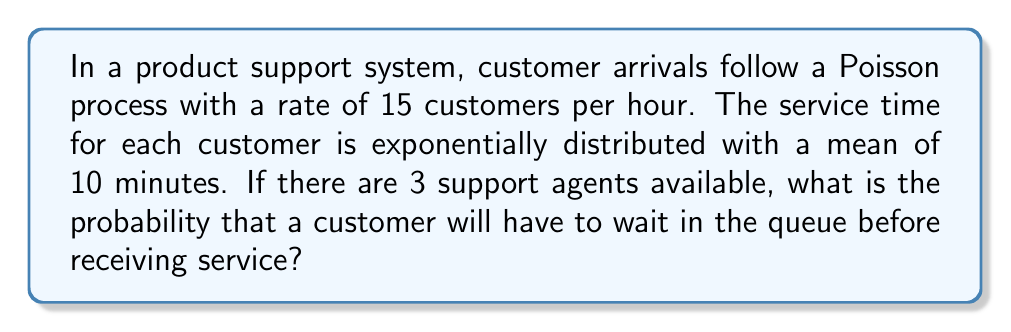What is the answer to this math problem? To solve this problem, we'll use the M/M/c queuing model, where M/M indicates Markovian arrival and service processes, and c is the number of servers (support agents in this case).

Step 1: Calculate the arrival rate (λ) and service rate (μ)
λ = 15 customers/hour
μ = 1 / (10/60) = 6 customers/hour (converting 10 minutes to hours)

Step 2: Calculate the utilization factor (ρ)
$$\rho = \frac{\lambda}{c\mu} = \frac{15}{3 \cdot 6} = \frac{5}{6} \approx 0.833$$

Step 3: Calculate the probability of zero customers in the system (P₀)
$$P_0 = \left[\sum_{n=0}^{c-1}\frac{(c\rho)^n}{n!} + \frac{(c\rho)^c}{c!(1-\rho)}\right]^{-1}$$

Substituting the values:
$$P_0 = \left[\frac{(3 \cdot \frac{5}{6})^0}{0!} + \frac{(3 \cdot \frac{5}{6})^1}{1!} + \frac{(3 \cdot \frac{5}{6})^2}{2!} + \frac{(3 \cdot \frac{5}{6})^3}{3!(1-\frac{5}{6})}\right]^{-1}$$

$$P_0 = \left[1 + 2.5 + 3.125 + 9.375\right]^{-1} \approx 0.0625$$

Step 4: Calculate the probability that a customer will have to wait (P_w)
$$P_w = \frac{(c\rho)^c}{c!(1-\rho)} P_0$$

Substituting the values:
$$P_w = \frac{(3 \cdot \frac{5}{6})^3}{3!(1-\frac{5}{6})} \cdot 0.0625 \approx 0.5859$$

Therefore, the probability that a customer will have to wait in the queue before receiving service is approximately 0.5859 or 58.59%.
Answer: 0.5859 